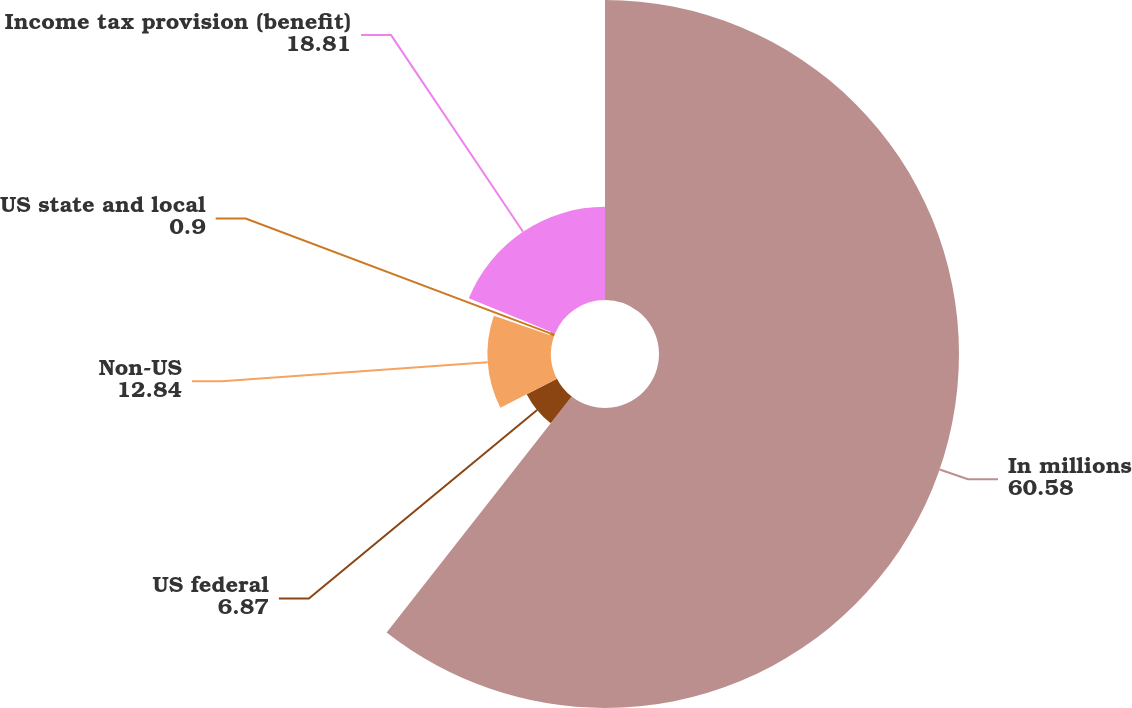Convert chart to OTSL. <chart><loc_0><loc_0><loc_500><loc_500><pie_chart><fcel>In millions<fcel>US federal<fcel>Non-US<fcel>US state and local<fcel>Income tax provision (benefit)<nl><fcel>60.58%<fcel>6.87%<fcel>12.84%<fcel>0.9%<fcel>18.81%<nl></chart> 